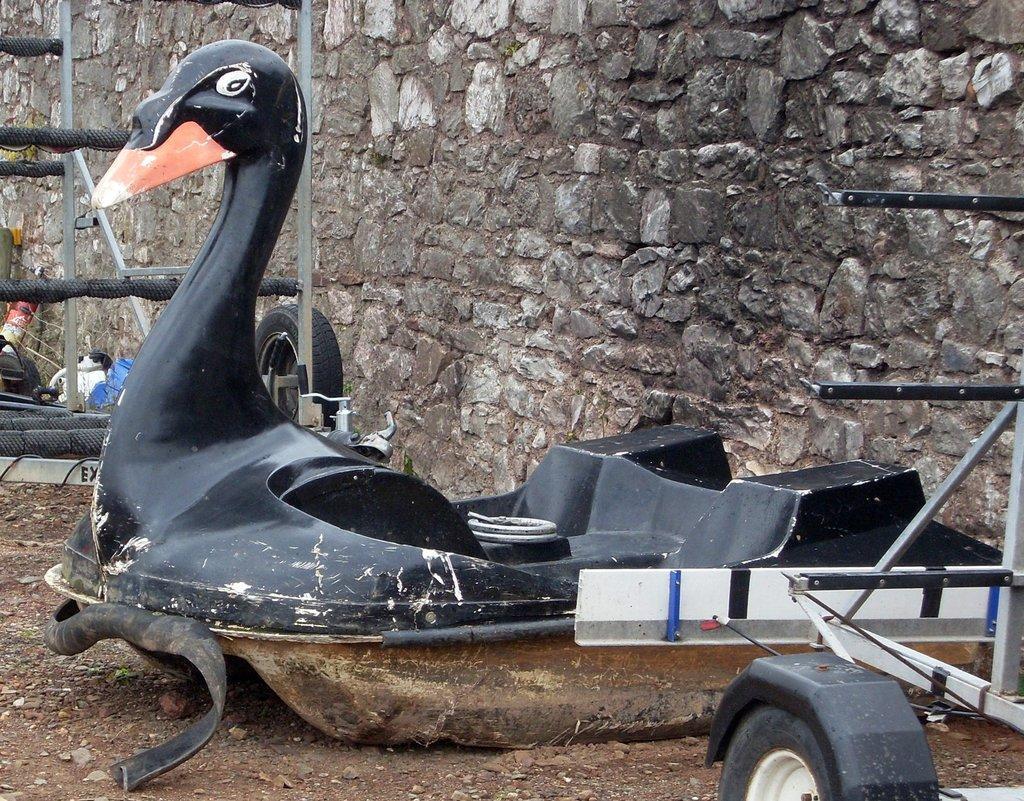Please provide a concise description of this image. In this image we can see duck shape vehicle. Behind the vehicle wall is there and metal thing is present. Right bottom of the image type is present which is attached to metal rods. 